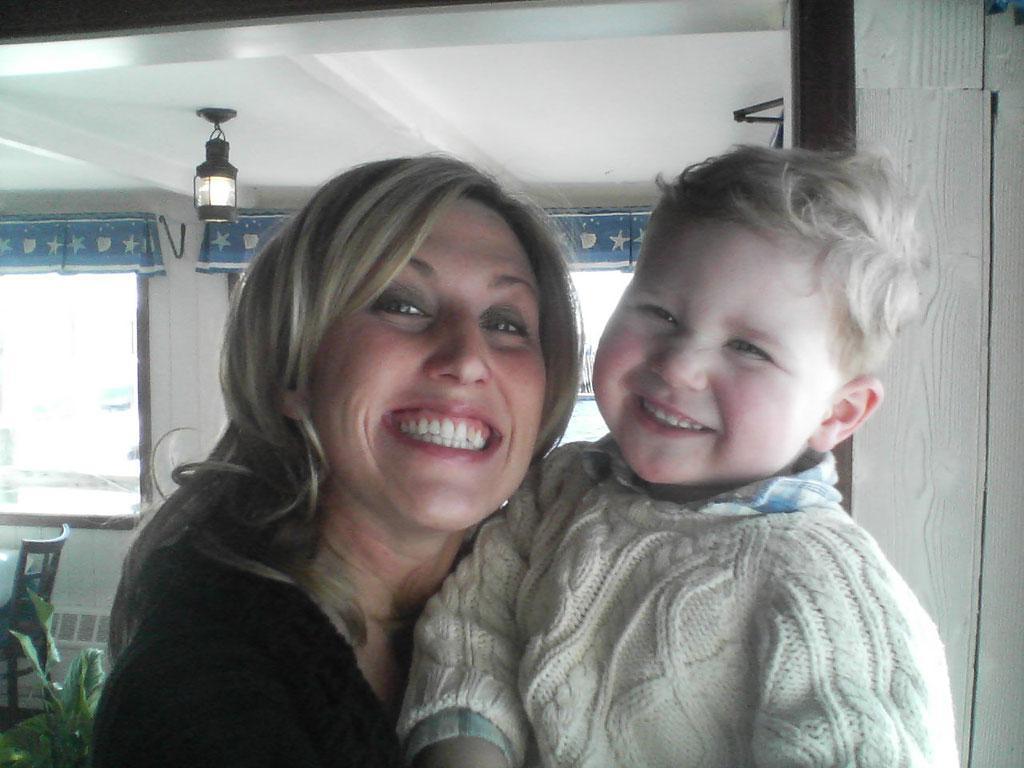Could you give a brief overview of what you see in this image? There is a woman and boy smiling. In the background we can see wall,windows,plants and chair. At the top we can see light. 